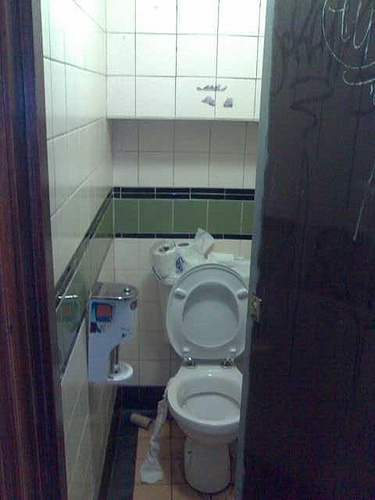Describe the objects in this image and their specific colors. I can see a toilet in black, gray, and darkgray tones in this image. 